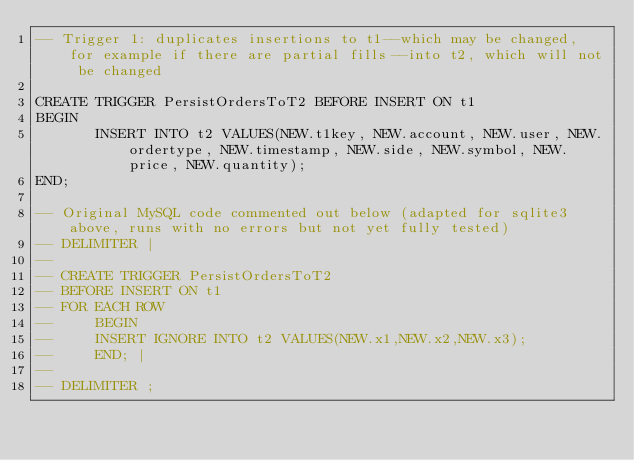<code> <loc_0><loc_0><loc_500><loc_500><_SQL_>-- Trigger 1: duplicates insertions to t1--which may be changed, for example if there are partial fills--into t2, which will not be changed

CREATE TRIGGER PersistOrdersToT2 BEFORE INSERT ON t1
BEGIN
	   INSERT INTO t2 VALUES(NEW.t1key, NEW.account, NEW.user, NEW.ordertype, NEW.timestamp, NEW.side, NEW.symbol, NEW.price, NEW.quantity);
END;

-- Original MySQL code commented out below (adapted for sqlite3 above, runs with no errors but not yet fully tested)
-- DELIMITER |
-- 	  
-- CREATE TRIGGER PersistOrdersToT2
-- BEFORE INSERT ON t1
-- FOR EACH ROW
--     BEGIN
-- 	   INSERT IGNORE INTO t2 VALUES(NEW.x1,NEW.x2,NEW.x3);
--     END; |
-- 				    
-- DELIMITER ;</code> 